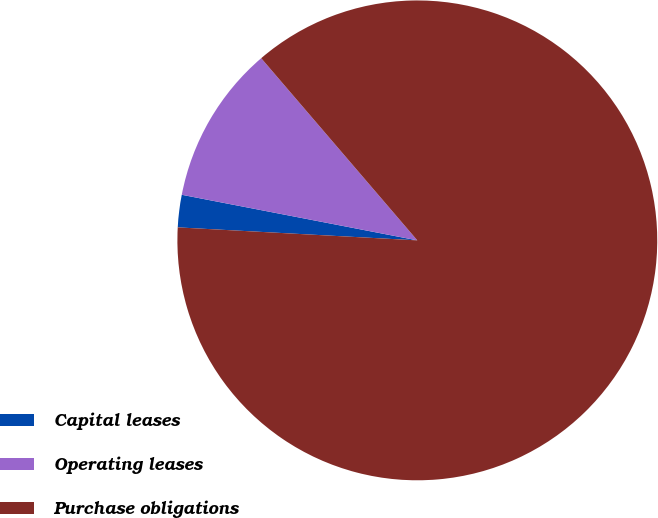<chart> <loc_0><loc_0><loc_500><loc_500><pie_chart><fcel>Capital leases<fcel>Operating leases<fcel>Purchase obligations<nl><fcel>2.18%<fcel>10.68%<fcel>87.14%<nl></chart> 